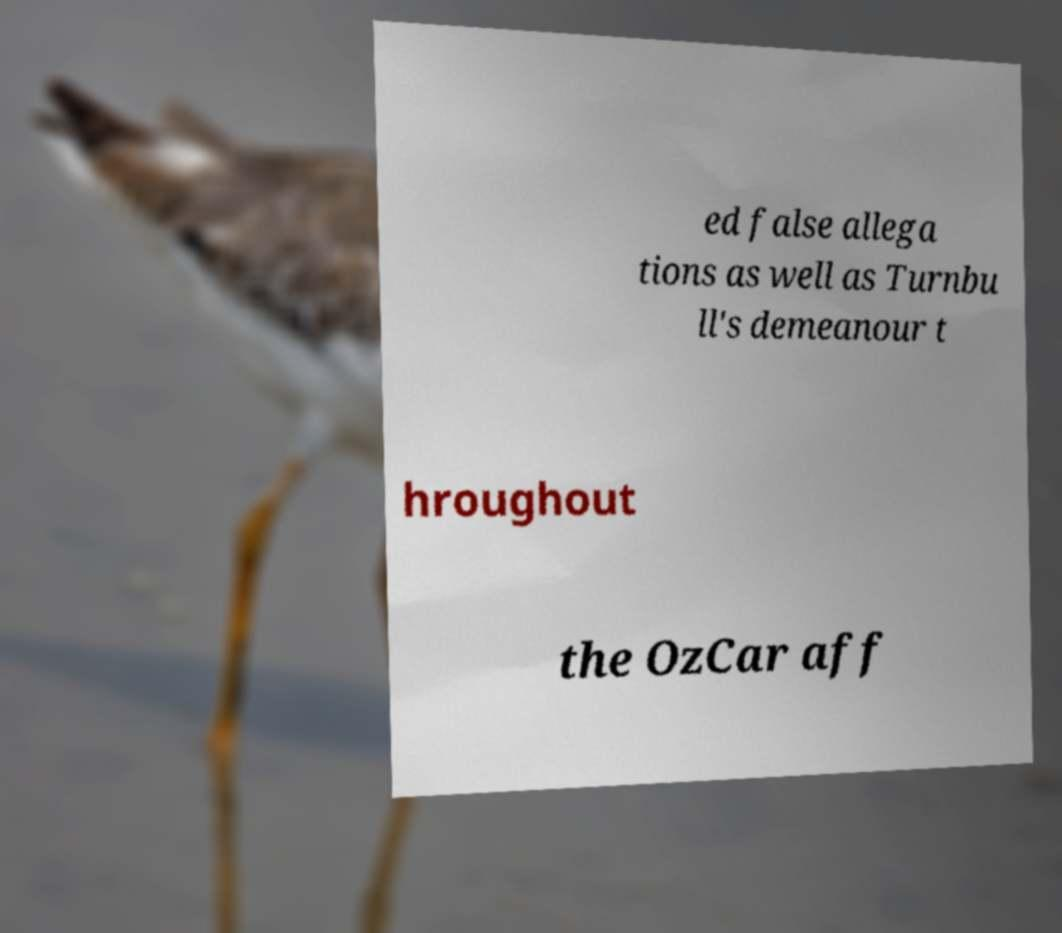Can you read and provide the text displayed in the image?This photo seems to have some interesting text. Can you extract and type it out for me? ed false allega tions as well as Turnbu ll's demeanour t hroughout the OzCar aff 